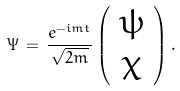<formula> <loc_0><loc_0><loc_500><loc_500>\Psi \, = \, \frac { e ^ { - i m t } } { \sqrt { 2 m } } \left ( \begin{array} { c } \psi \\ \chi \end{array} \right ) .</formula> 